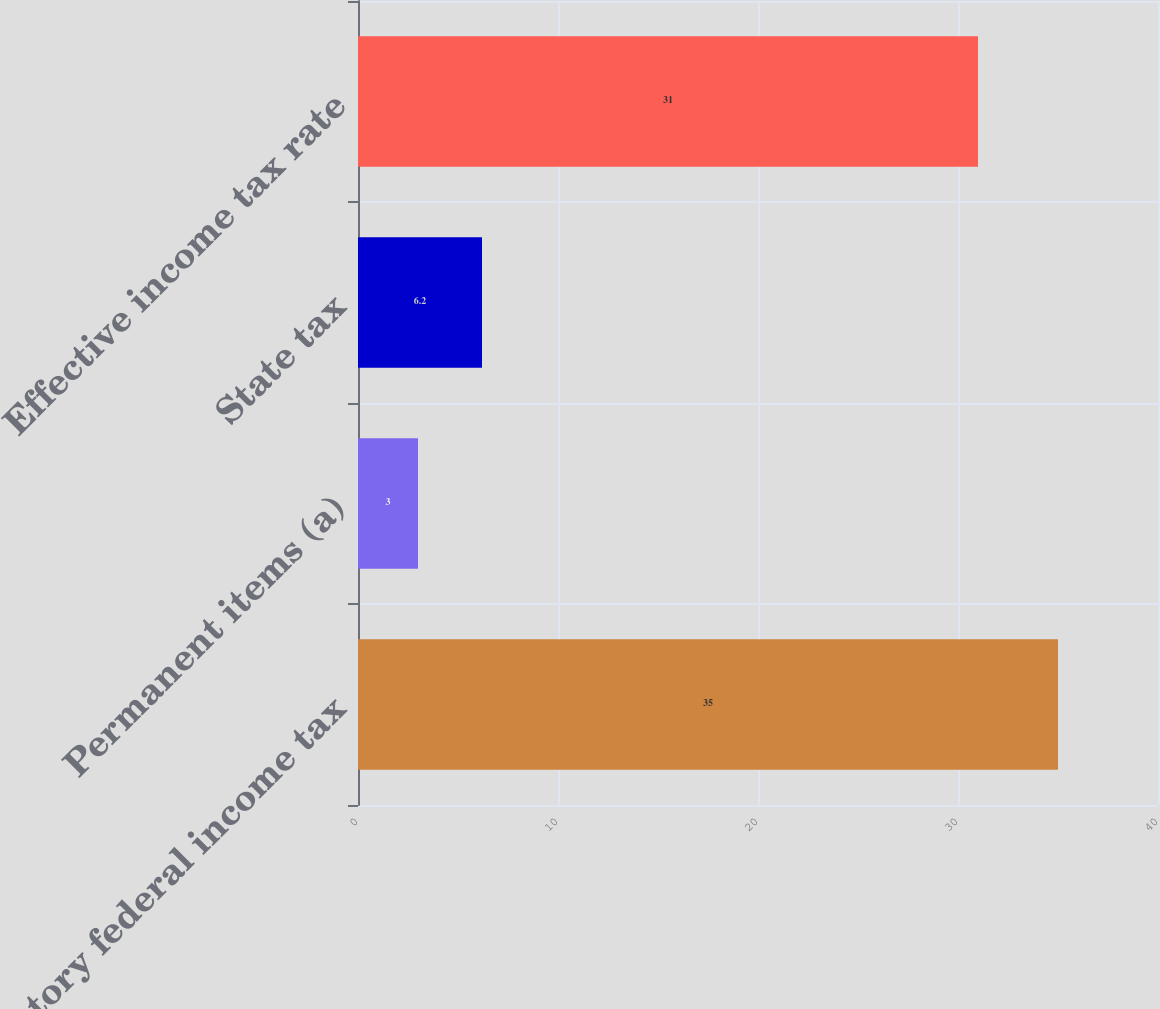<chart> <loc_0><loc_0><loc_500><loc_500><bar_chart><fcel>Statutory federal income tax<fcel>Permanent items (a)<fcel>State tax<fcel>Effective income tax rate<nl><fcel>35<fcel>3<fcel>6.2<fcel>31<nl></chart> 